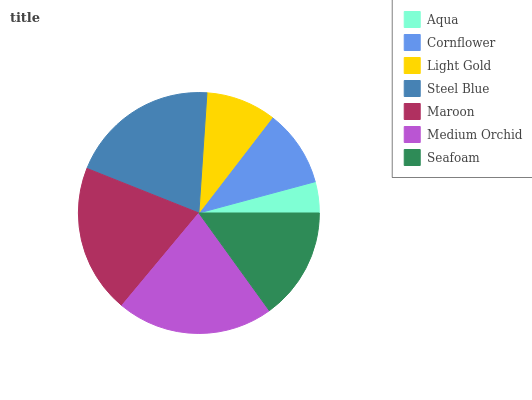Is Aqua the minimum?
Answer yes or no. Yes. Is Medium Orchid the maximum?
Answer yes or no. Yes. Is Cornflower the minimum?
Answer yes or no. No. Is Cornflower the maximum?
Answer yes or no. No. Is Cornflower greater than Aqua?
Answer yes or no. Yes. Is Aqua less than Cornflower?
Answer yes or no. Yes. Is Aqua greater than Cornflower?
Answer yes or no. No. Is Cornflower less than Aqua?
Answer yes or no. No. Is Seafoam the high median?
Answer yes or no. Yes. Is Seafoam the low median?
Answer yes or no. Yes. Is Steel Blue the high median?
Answer yes or no. No. Is Maroon the low median?
Answer yes or no. No. 